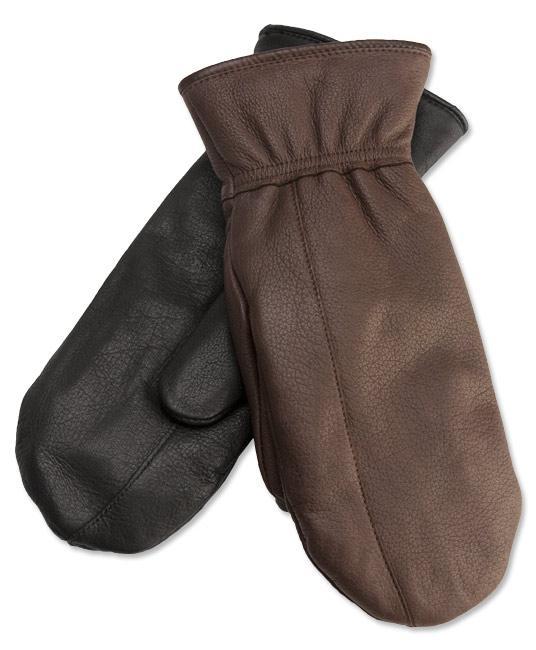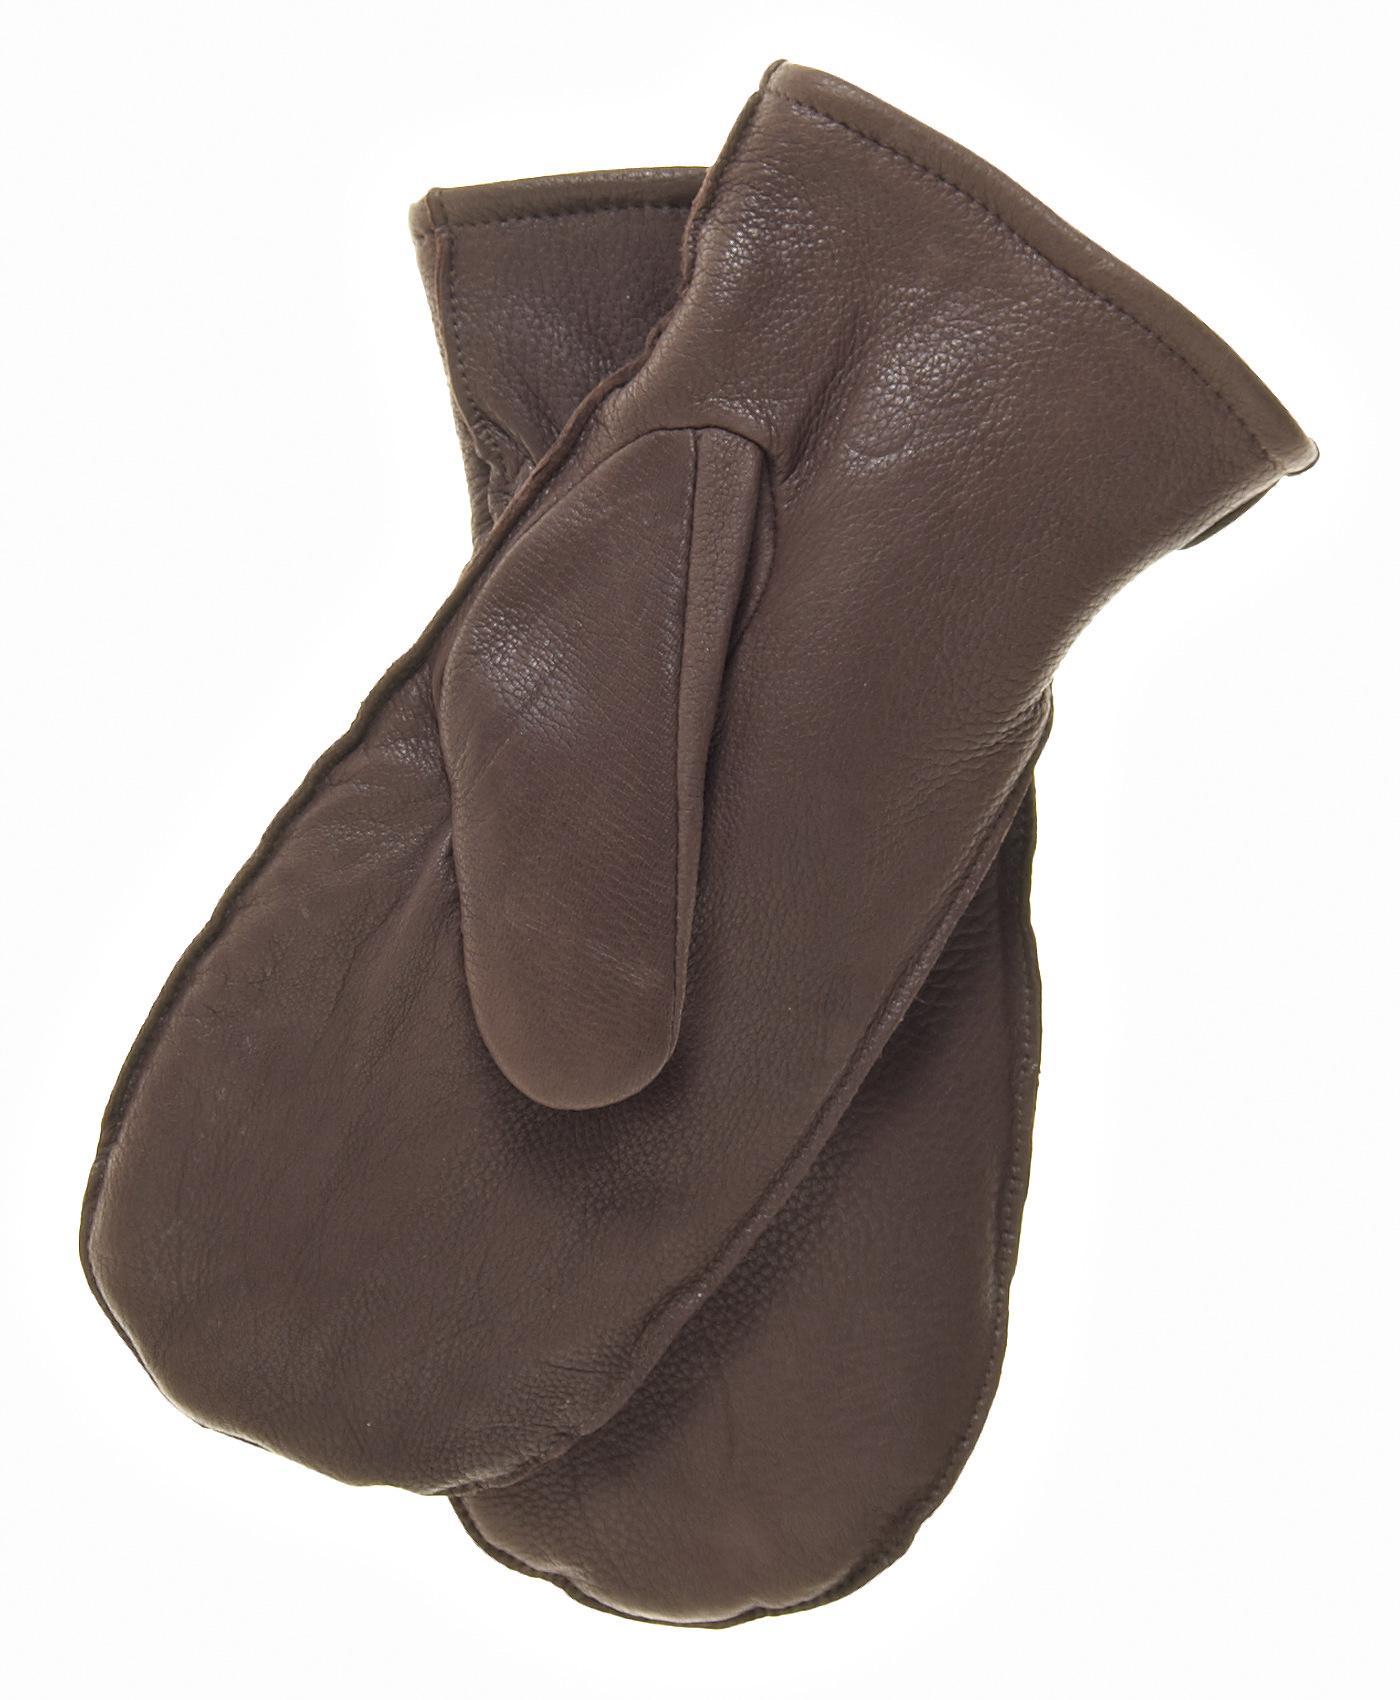The first image is the image on the left, the second image is the image on the right. Evaluate the accuracy of this statement regarding the images: "Each image shows exactly two mittens, and each pair of mittens is displayed with the two mittens overlapping.". Is it true? Answer yes or no. Yes. 